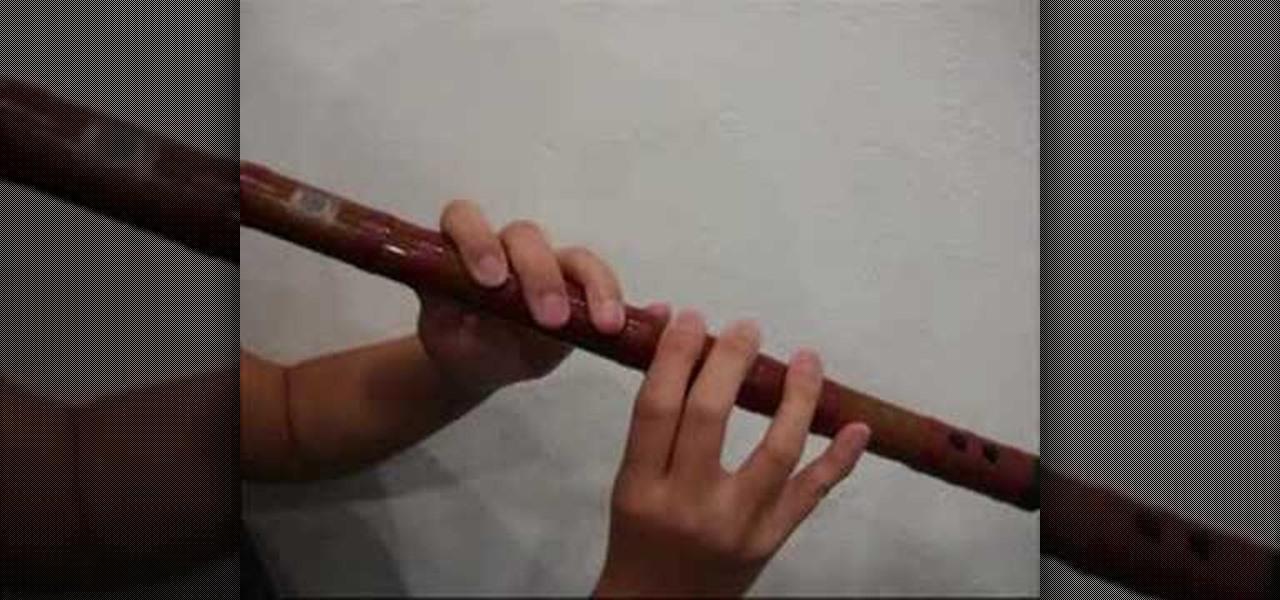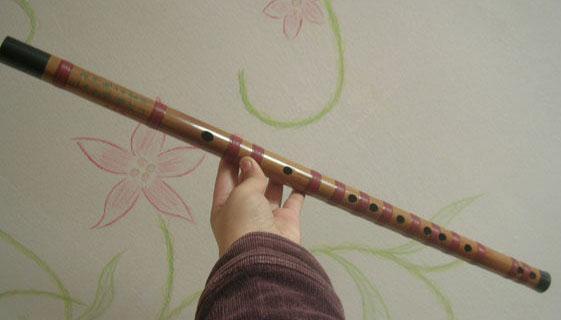The first image is the image on the left, the second image is the image on the right. For the images displayed, is the sentence "The combined images contain exactly 5 pipe shapes with at least one flat end, and the images include at least one pipe shape perforated with holes on its side." factually correct? Answer yes or no. No. The first image is the image on the left, the second image is the image on the right. Analyze the images presented: Is the assertion "In at least one image there are two small flutes." valid? Answer yes or no. No. 